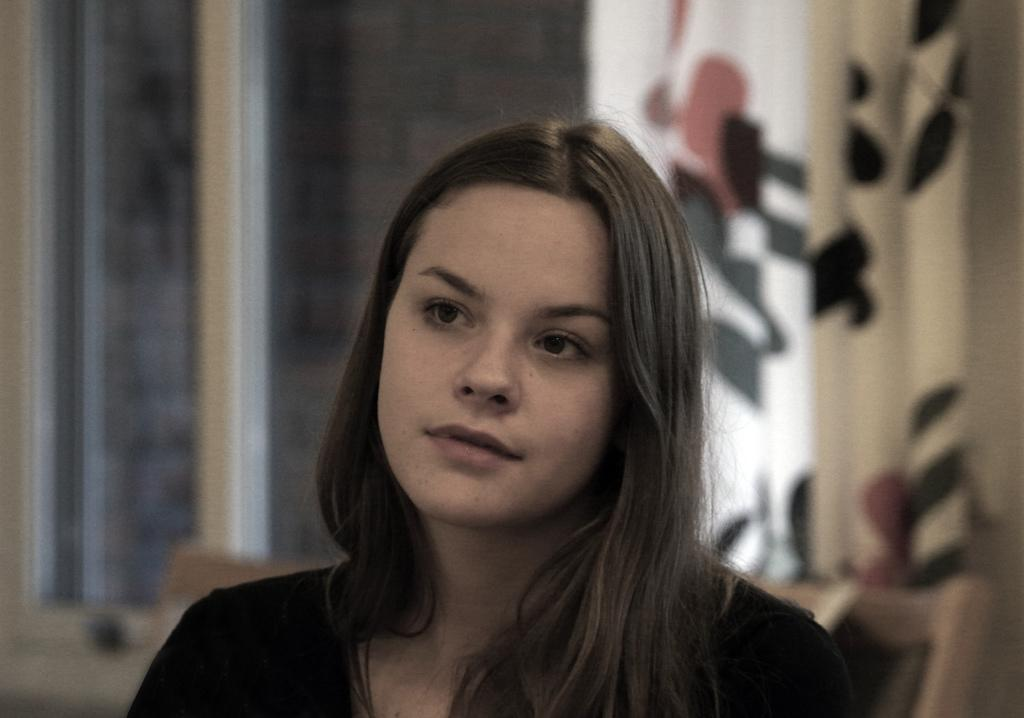Who is the main subject in the foreground of the image? There is a woman in the foreground of the image. What can be seen in the background of the image? There are windows in the background of the image. Are there any window treatments visible in the image? Yes, there are curtains associated with the windows in the background of the image. What type of shoes is the woman wearing in the image? There is no information about shoes in the image, as the focus is on the woman, windows, and curtains. 